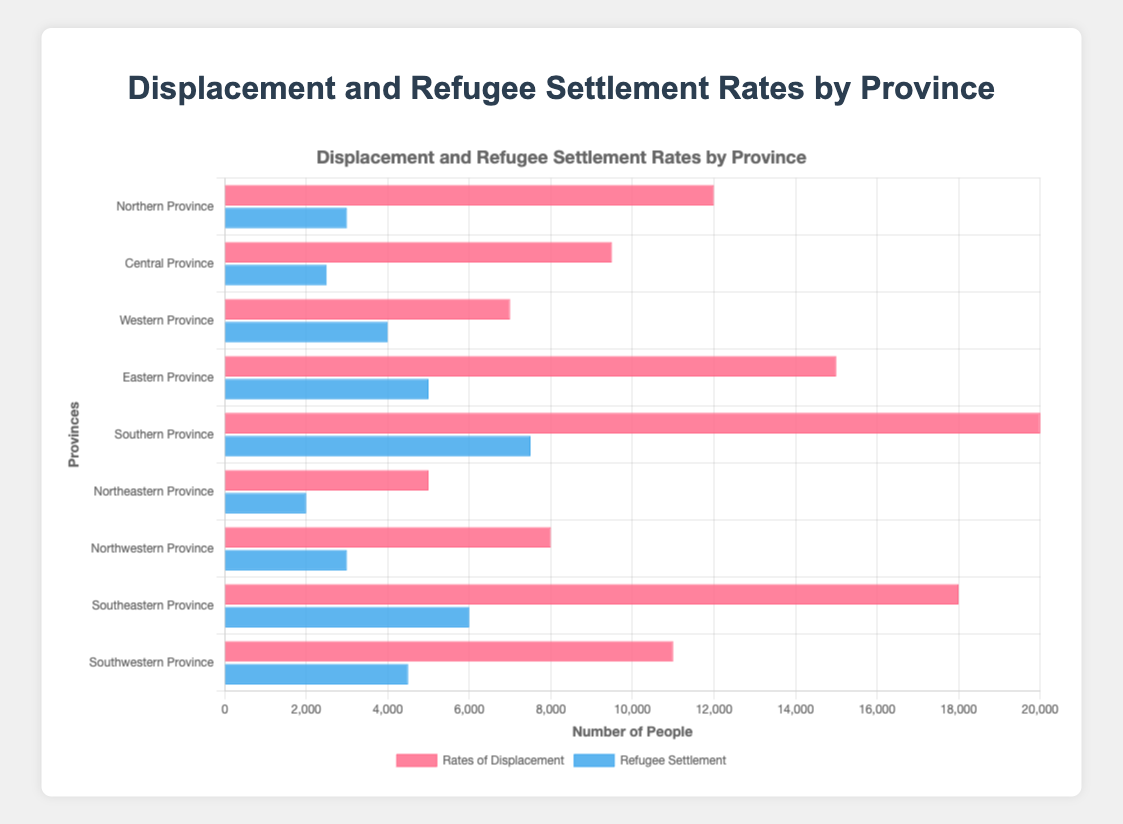Which region has the highest number of displaced individuals? By looking at the plot, the region with the longest bar for 'Rates of Displacement' represents the region with the highest number of displaced individuals.
Answer: Southern Province What is the combined total of displaced individuals for the Northern and Eastern Provinces? Add the rates of displacement for the Northern Province (12,000) and the Eastern Province (15,000) to get the total. 12,000 + 15,000 = 27,000
Answer: 27,000 How does the refugee settlement in Central Province compare to that in Northwestern Province? By comparing the length of the bars for 'Refugee Settlement' of both provinces, Central Province has a shorter bar (2,500) compared to Northwestern Province (3,000).
Answer: less Which region has the highest ratio of refugee settlement to rates of displacement? Calculate the ratio by dividing refugee settlement by rates of displacement for each region. Find the highest ratio among them.
Answer: Western Province What is the difference in rates of displacement between the Southern and Northeastern Provinces? Subtract the rates of displacement of Northeastern Province (5,000) from that of Southern Province (20,000). 20,000 - 5,000 = 15,000
Answer: 15,000 Which region has the least number of refugee settlements? The shortest bar representing 'Refugee Settlement' in the plot indicates the region with the least number of refugee settlements.
Answer: Northeastern Province How much more is the refugee settlement in Southern Province compared to Southwestern Province? Subtract the refugee settlement of Southwestern Province (4,500) from that of Southern Province (7,500). 7,500 - 4,500 = 3,000
Answer: 3,000 What is the average rate of displacement across all regions? Add the rates of displacement for all regions and divide by the number of regions. (12,000 + 9,500 + 7,000 + 15,000 + 20,000 + 5,000 + 8,000 + 18,000 + 11,000) / 9 = 11,611
Answer: 11,611 Which region has the greater discrepancy between rates of displacement and refugee settlements? Calculate the differences between rates of displacement and refugee settlements for each region and identify the maximum difference.
Answer: Southern Province What is the total number of refugee settlements in the central and southeastern regions? Add the refugee settlements for the Central Province (2,500) and Southeastern Province (6,000). 2,500 + 6,000 = 8,500
Answer: 8,500 